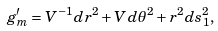Convert formula to latex. <formula><loc_0><loc_0><loc_500><loc_500>g _ { m } ^ { \prime } = V ^ { - 1 } d r ^ { 2 } + V d \theta ^ { 2 } + r ^ { 2 } d s _ { 1 } ^ { 2 } ,</formula> 